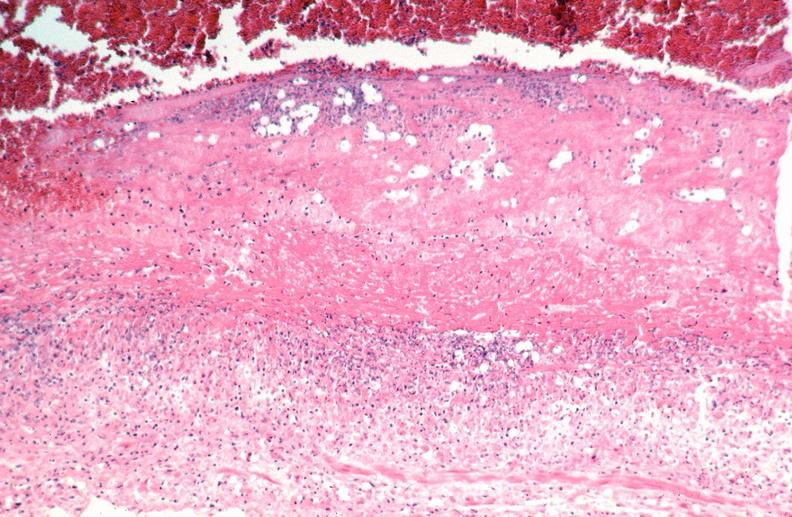s opened muscle present?
Answer the question using a single word or phrase. No 